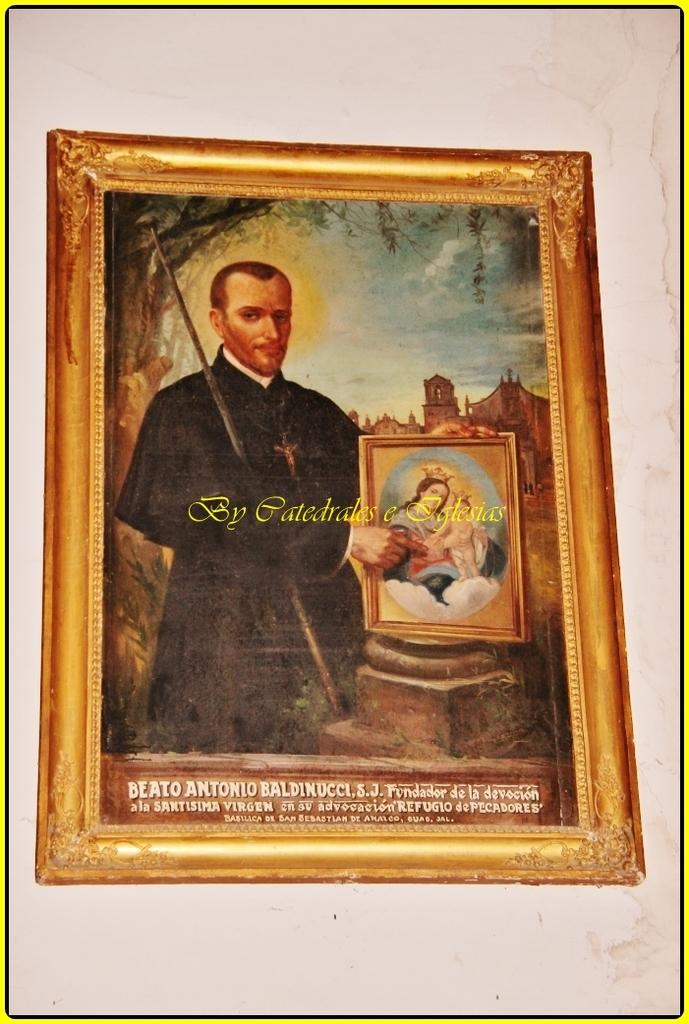<image>
Render a clear and concise summary of the photo. A painting of a man holding a panting by Catedrales e Iglesias 